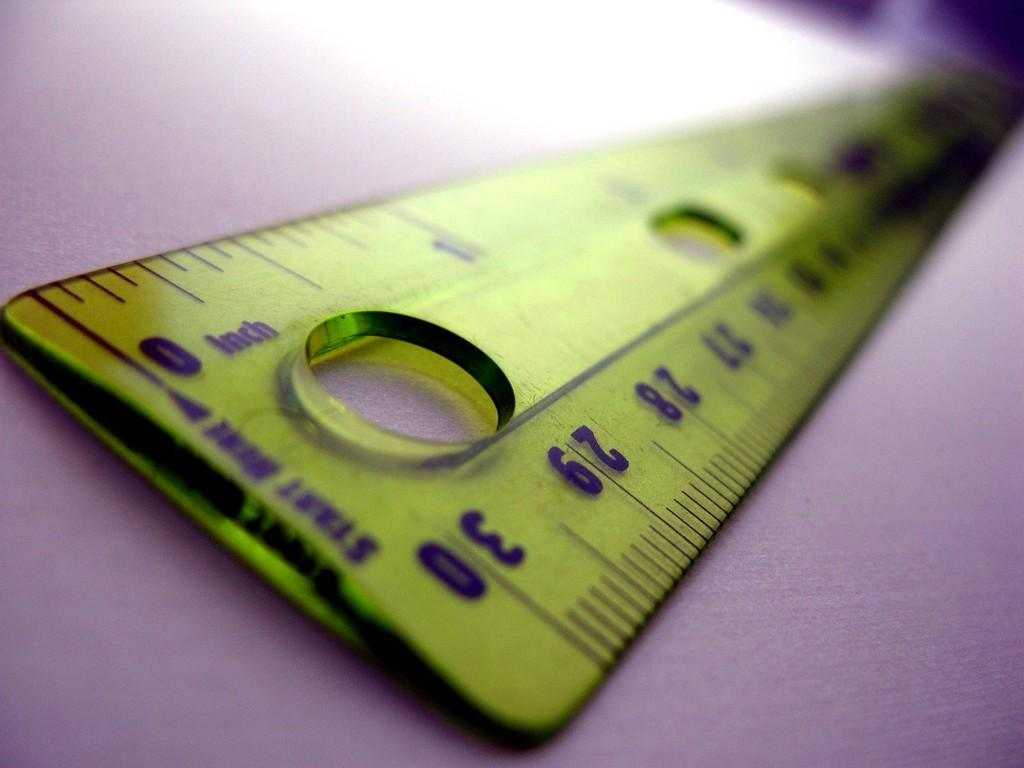<image>
Offer a succinct explanation of the picture presented. A yellow ruler that has the number thirty on the end. 